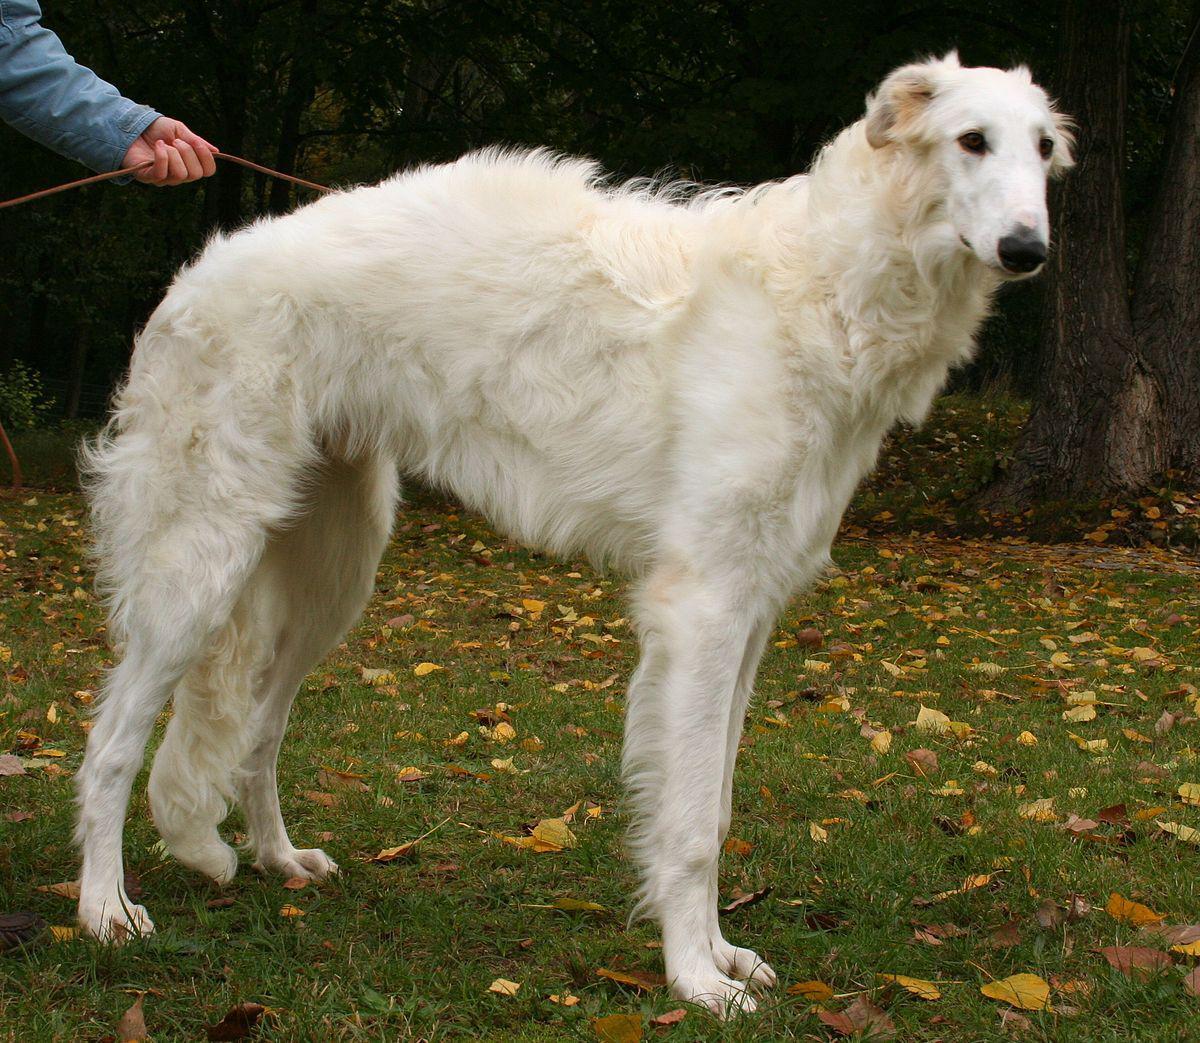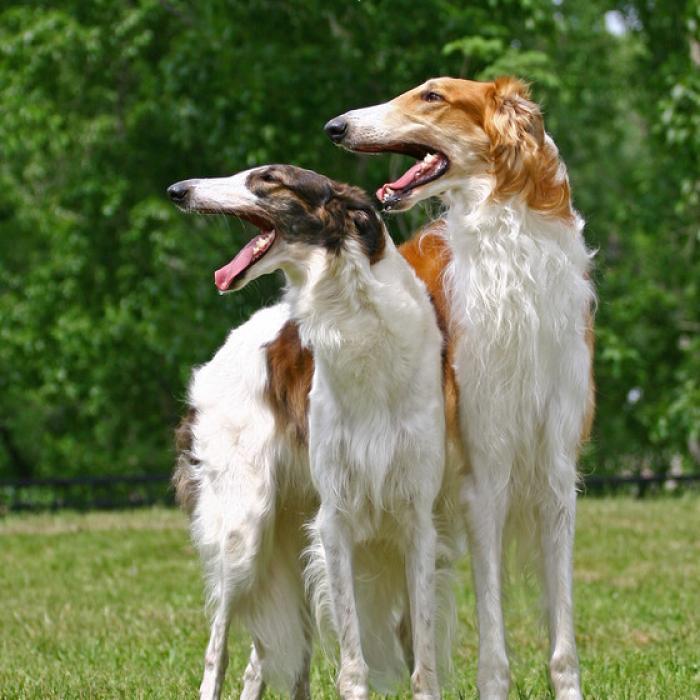The first image is the image on the left, the second image is the image on the right. Given the left and right images, does the statement "An image shows two hounds interacting face-to-face." hold true? Answer yes or no. No. 